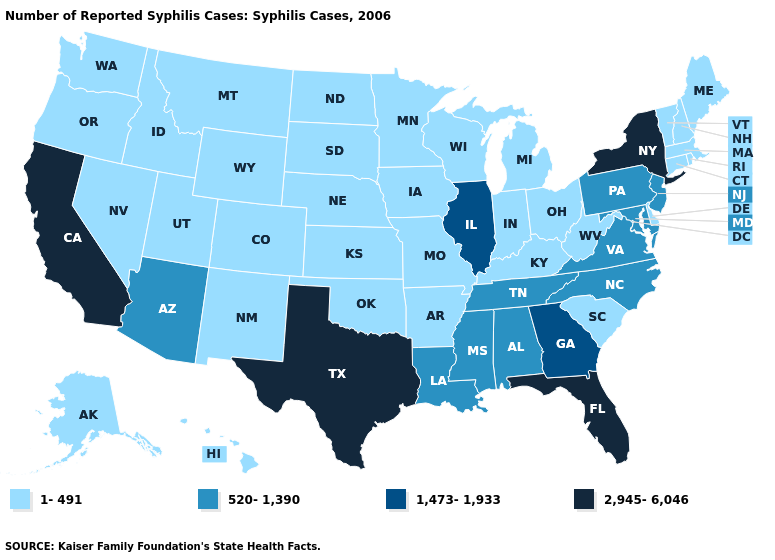Name the states that have a value in the range 520-1,390?
Keep it brief. Alabama, Arizona, Louisiana, Maryland, Mississippi, New Jersey, North Carolina, Pennsylvania, Tennessee, Virginia. How many symbols are there in the legend?
Be succinct. 4. What is the lowest value in the Northeast?
Concise answer only. 1-491. Name the states that have a value in the range 520-1,390?
Answer briefly. Alabama, Arizona, Louisiana, Maryland, Mississippi, New Jersey, North Carolina, Pennsylvania, Tennessee, Virginia. Name the states that have a value in the range 520-1,390?
Quick response, please. Alabama, Arizona, Louisiana, Maryland, Mississippi, New Jersey, North Carolina, Pennsylvania, Tennessee, Virginia. Which states have the lowest value in the USA?
Write a very short answer. Alaska, Arkansas, Colorado, Connecticut, Delaware, Hawaii, Idaho, Indiana, Iowa, Kansas, Kentucky, Maine, Massachusetts, Michigan, Minnesota, Missouri, Montana, Nebraska, Nevada, New Hampshire, New Mexico, North Dakota, Ohio, Oklahoma, Oregon, Rhode Island, South Carolina, South Dakota, Utah, Vermont, Washington, West Virginia, Wisconsin, Wyoming. What is the lowest value in the USA?
Short answer required. 1-491. Among the states that border New Mexico , which have the lowest value?
Give a very brief answer. Colorado, Oklahoma, Utah. Does the first symbol in the legend represent the smallest category?
Answer briefly. Yes. Among the states that border Arizona , which have the lowest value?
Concise answer only. Colorado, Nevada, New Mexico, Utah. What is the lowest value in states that border Connecticut?
Concise answer only. 1-491. Name the states that have a value in the range 2,945-6,046?
Be succinct. California, Florida, New York, Texas. What is the value of South Carolina?
Keep it brief. 1-491. What is the value of Colorado?
Be succinct. 1-491. Among the states that border Kentucky , does Indiana have the highest value?
Short answer required. No. 